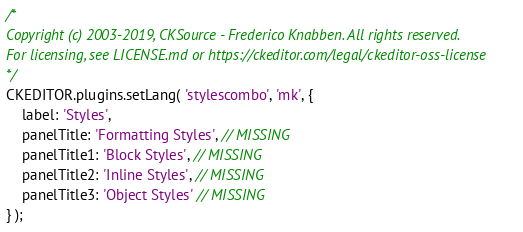Convert code to text. <code><loc_0><loc_0><loc_500><loc_500><_JavaScript_>/*
Copyright (c) 2003-2019, CKSource - Frederico Knabben. All rights reserved.
For licensing, see LICENSE.md or https://ckeditor.com/legal/ckeditor-oss-license
*/
CKEDITOR.plugins.setLang( 'stylescombo', 'mk', {
	label: 'Styles',
	panelTitle: 'Formatting Styles', // MISSING
	panelTitle1: 'Block Styles', // MISSING
	panelTitle2: 'Inline Styles', // MISSING
	panelTitle3: 'Object Styles' // MISSING
} );
</code> 